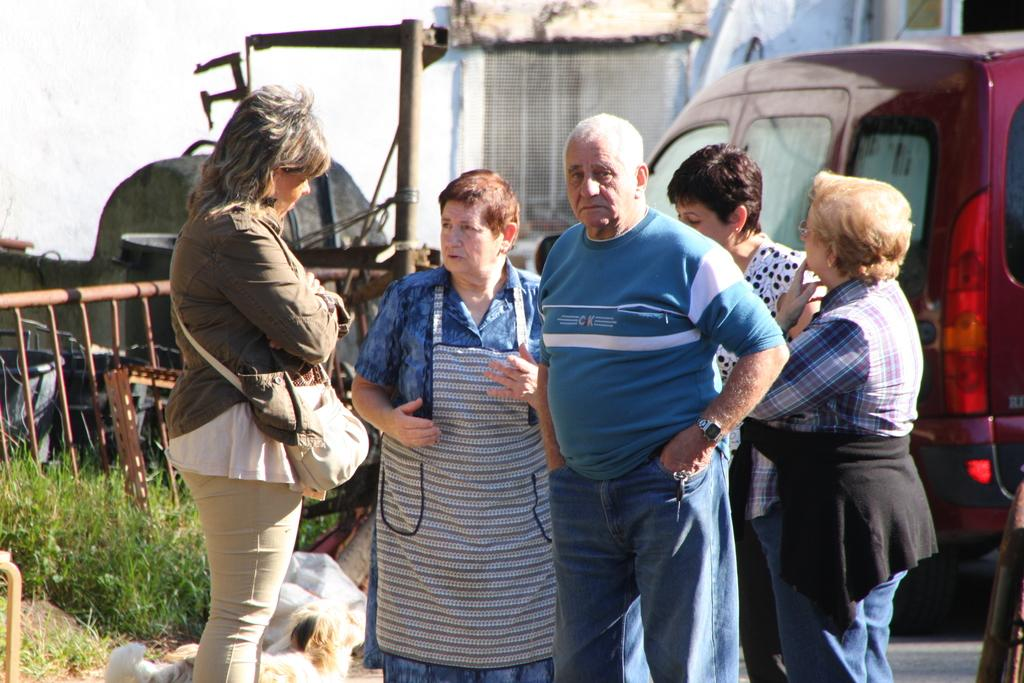How many people are standing on the road in the foreground? There are five persons standing on the road in the foreground. What can be seen in the background of the image? In the background, there is a car, grass, a fence, and houses. What time of day was the image taken? The image was taken during the day. How many trucks are parked next to the fence in the image? There are no trucks visible in the image; only a car, grass, a fence, and houses can be seen in the background. What type of stick can be seen leaning against the fence in the image? There is no stick present in the image. 